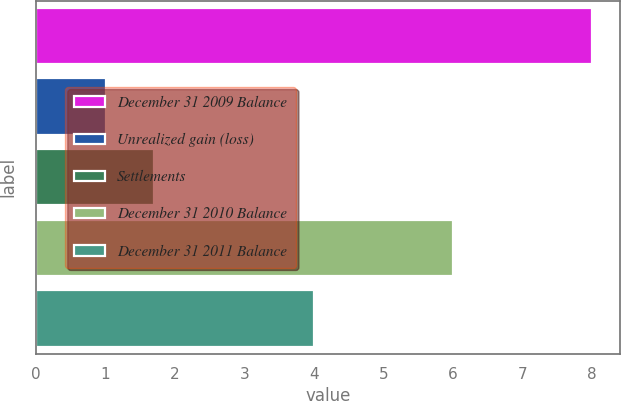<chart> <loc_0><loc_0><loc_500><loc_500><bar_chart><fcel>December 31 2009 Balance<fcel>Unrealized gain (loss)<fcel>Settlements<fcel>December 31 2010 Balance<fcel>December 31 2011 Balance<nl><fcel>8<fcel>1<fcel>1.7<fcel>6<fcel>4<nl></chart> 